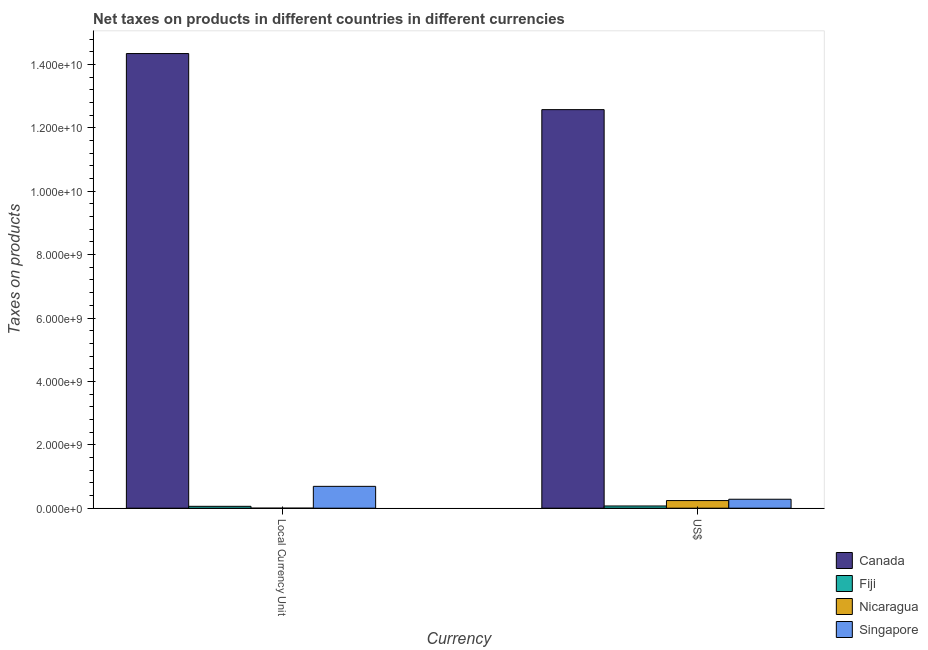How many bars are there on the 1st tick from the right?
Provide a succinct answer. 4. What is the label of the 1st group of bars from the left?
Keep it short and to the point. Local Currency Unit. What is the net taxes in constant 2005 us$ in Canada?
Your answer should be very brief. 1.43e+1. Across all countries, what is the maximum net taxes in us$?
Your response must be concise. 1.26e+1. Across all countries, what is the minimum net taxes in us$?
Make the answer very short. 6.99e+07. In which country was the net taxes in us$ minimum?
Offer a terse response. Fiji. What is the total net taxes in us$ in the graph?
Offer a very short reply. 1.32e+1. What is the difference between the net taxes in constant 2005 us$ in Canada and that in Singapore?
Make the answer very short. 1.37e+1. What is the difference between the net taxes in constant 2005 us$ in Nicaragua and the net taxes in us$ in Singapore?
Ensure brevity in your answer.  -2.82e+08. What is the average net taxes in constant 2005 us$ per country?
Offer a terse response. 3.77e+09. What is the difference between the net taxes in constant 2005 us$ and net taxes in us$ in Singapore?
Give a very brief answer. 4.07e+08. In how many countries, is the net taxes in us$ greater than 2800000000 units?
Ensure brevity in your answer.  1. What is the ratio of the net taxes in constant 2005 us$ in Fiji to that in Nicaragua?
Provide a short and direct response. 1.75e+08. Is the net taxes in us$ in Fiji less than that in Nicaragua?
Provide a succinct answer. Yes. In how many countries, is the net taxes in constant 2005 us$ greater than the average net taxes in constant 2005 us$ taken over all countries?
Make the answer very short. 1. What does the 4th bar from the left in Local Currency Unit represents?
Your response must be concise. Singapore. What does the 2nd bar from the right in Local Currency Unit represents?
Make the answer very short. Nicaragua. Does the graph contain any zero values?
Provide a succinct answer. No. Does the graph contain grids?
Your answer should be compact. No. Where does the legend appear in the graph?
Provide a succinct answer. Bottom right. How many legend labels are there?
Offer a very short reply. 4. What is the title of the graph?
Offer a terse response. Net taxes on products in different countries in different currencies. What is the label or title of the X-axis?
Ensure brevity in your answer.  Currency. What is the label or title of the Y-axis?
Provide a short and direct response. Taxes on products. What is the Taxes on products of Canada in Local Currency Unit?
Your response must be concise. 1.43e+1. What is the Taxes on products in Fiji in Local Currency Unit?
Provide a succinct answer. 5.92e+07. What is the Taxes on products of Nicaragua in Local Currency Unit?
Offer a terse response. 0.34. What is the Taxes on products of Singapore in Local Currency Unit?
Your response must be concise. 6.89e+08. What is the Taxes on products in Canada in US$?
Keep it short and to the point. 1.26e+1. What is the Taxes on products in Fiji in US$?
Offer a very short reply. 6.99e+07. What is the Taxes on products in Nicaragua in US$?
Keep it short and to the point. 2.40e+08. What is the Taxes on products in Singapore in US$?
Offer a very short reply. 2.82e+08. Across all Currency, what is the maximum Taxes on products in Canada?
Keep it short and to the point. 1.43e+1. Across all Currency, what is the maximum Taxes on products in Fiji?
Provide a short and direct response. 6.99e+07. Across all Currency, what is the maximum Taxes on products in Nicaragua?
Provide a succinct answer. 2.40e+08. Across all Currency, what is the maximum Taxes on products of Singapore?
Offer a terse response. 6.89e+08. Across all Currency, what is the minimum Taxes on products in Canada?
Keep it short and to the point. 1.26e+1. Across all Currency, what is the minimum Taxes on products in Fiji?
Keep it short and to the point. 5.92e+07. Across all Currency, what is the minimum Taxes on products of Nicaragua?
Provide a short and direct response. 0.34. Across all Currency, what is the minimum Taxes on products in Singapore?
Keep it short and to the point. 2.82e+08. What is the total Taxes on products in Canada in the graph?
Provide a short and direct response. 2.69e+1. What is the total Taxes on products of Fiji in the graph?
Provide a succinct answer. 1.29e+08. What is the total Taxes on products of Nicaragua in the graph?
Give a very brief answer. 2.40e+08. What is the total Taxes on products of Singapore in the graph?
Give a very brief answer. 9.71e+08. What is the difference between the Taxes on products in Canada in Local Currency Unit and that in US$?
Keep it short and to the point. 1.77e+09. What is the difference between the Taxes on products of Fiji in Local Currency Unit and that in US$?
Make the answer very short. -1.07e+07. What is the difference between the Taxes on products in Nicaragua in Local Currency Unit and that in US$?
Offer a terse response. -2.40e+08. What is the difference between the Taxes on products of Singapore in Local Currency Unit and that in US$?
Offer a very short reply. 4.07e+08. What is the difference between the Taxes on products in Canada in Local Currency Unit and the Taxes on products in Fiji in US$?
Offer a terse response. 1.43e+1. What is the difference between the Taxes on products in Canada in Local Currency Unit and the Taxes on products in Nicaragua in US$?
Give a very brief answer. 1.41e+1. What is the difference between the Taxes on products in Canada in Local Currency Unit and the Taxes on products in Singapore in US$?
Your answer should be compact. 1.41e+1. What is the difference between the Taxes on products in Fiji in Local Currency Unit and the Taxes on products in Nicaragua in US$?
Make the answer very short. -1.81e+08. What is the difference between the Taxes on products of Fiji in Local Currency Unit and the Taxes on products of Singapore in US$?
Give a very brief answer. -2.23e+08. What is the difference between the Taxes on products of Nicaragua in Local Currency Unit and the Taxes on products of Singapore in US$?
Your answer should be very brief. -2.82e+08. What is the average Taxes on products in Canada per Currency?
Keep it short and to the point. 1.35e+1. What is the average Taxes on products of Fiji per Currency?
Provide a short and direct response. 6.46e+07. What is the average Taxes on products of Nicaragua per Currency?
Offer a terse response. 1.20e+08. What is the average Taxes on products of Singapore per Currency?
Provide a succinct answer. 4.86e+08. What is the difference between the Taxes on products in Canada and Taxes on products in Fiji in Local Currency Unit?
Your response must be concise. 1.43e+1. What is the difference between the Taxes on products of Canada and Taxes on products of Nicaragua in Local Currency Unit?
Keep it short and to the point. 1.43e+1. What is the difference between the Taxes on products of Canada and Taxes on products of Singapore in Local Currency Unit?
Your answer should be compact. 1.37e+1. What is the difference between the Taxes on products of Fiji and Taxes on products of Nicaragua in Local Currency Unit?
Give a very brief answer. 5.92e+07. What is the difference between the Taxes on products in Fiji and Taxes on products in Singapore in Local Currency Unit?
Provide a succinct answer. -6.30e+08. What is the difference between the Taxes on products in Nicaragua and Taxes on products in Singapore in Local Currency Unit?
Keep it short and to the point. -6.89e+08. What is the difference between the Taxes on products in Canada and Taxes on products in Fiji in US$?
Your answer should be very brief. 1.25e+1. What is the difference between the Taxes on products of Canada and Taxes on products of Nicaragua in US$?
Provide a short and direct response. 1.23e+1. What is the difference between the Taxes on products of Canada and Taxes on products of Singapore in US$?
Give a very brief answer. 1.23e+1. What is the difference between the Taxes on products of Fiji and Taxes on products of Nicaragua in US$?
Your answer should be compact. -1.70e+08. What is the difference between the Taxes on products in Fiji and Taxes on products in Singapore in US$?
Give a very brief answer. -2.13e+08. What is the difference between the Taxes on products in Nicaragua and Taxes on products in Singapore in US$?
Offer a terse response. -4.21e+07. What is the ratio of the Taxes on products in Canada in Local Currency Unit to that in US$?
Keep it short and to the point. 1.14. What is the ratio of the Taxes on products in Fiji in Local Currency Unit to that in US$?
Make the answer very short. 0.85. What is the ratio of the Taxes on products of Nicaragua in Local Currency Unit to that in US$?
Offer a very short reply. 0. What is the ratio of the Taxes on products of Singapore in Local Currency Unit to that in US$?
Make the answer very short. 2.44. What is the difference between the highest and the second highest Taxes on products in Canada?
Your answer should be compact. 1.77e+09. What is the difference between the highest and the second highest Taxes on products of Fiji?
Provide a short and direct response. 1.07e+07. What is the difference between the highest and the second highest Taxes on products in Nicaragua?
Your response must be concise. 2.40e+08. What is the difference between the highest and the second highest Taxes on products in Singapore?
Your answer should be compact. 4.07e+08. What is the difference between the highest and the lowest Taxes on products in Canada?
Ensure brevity in your answer.  1.77e+09. What is the difference between the highest and the lowest Taxes on products of Fiji?
Provide a short and direct response. 1.07e+07. What is the difference between the highest and the lowest Taxes on products in Nicaragua?
Provide a short and direct response. 2.40e+08. What is the difference between the highest and the lowest Taxes on products of Singapore?
Offer a very short reply. 4.07e+08. 